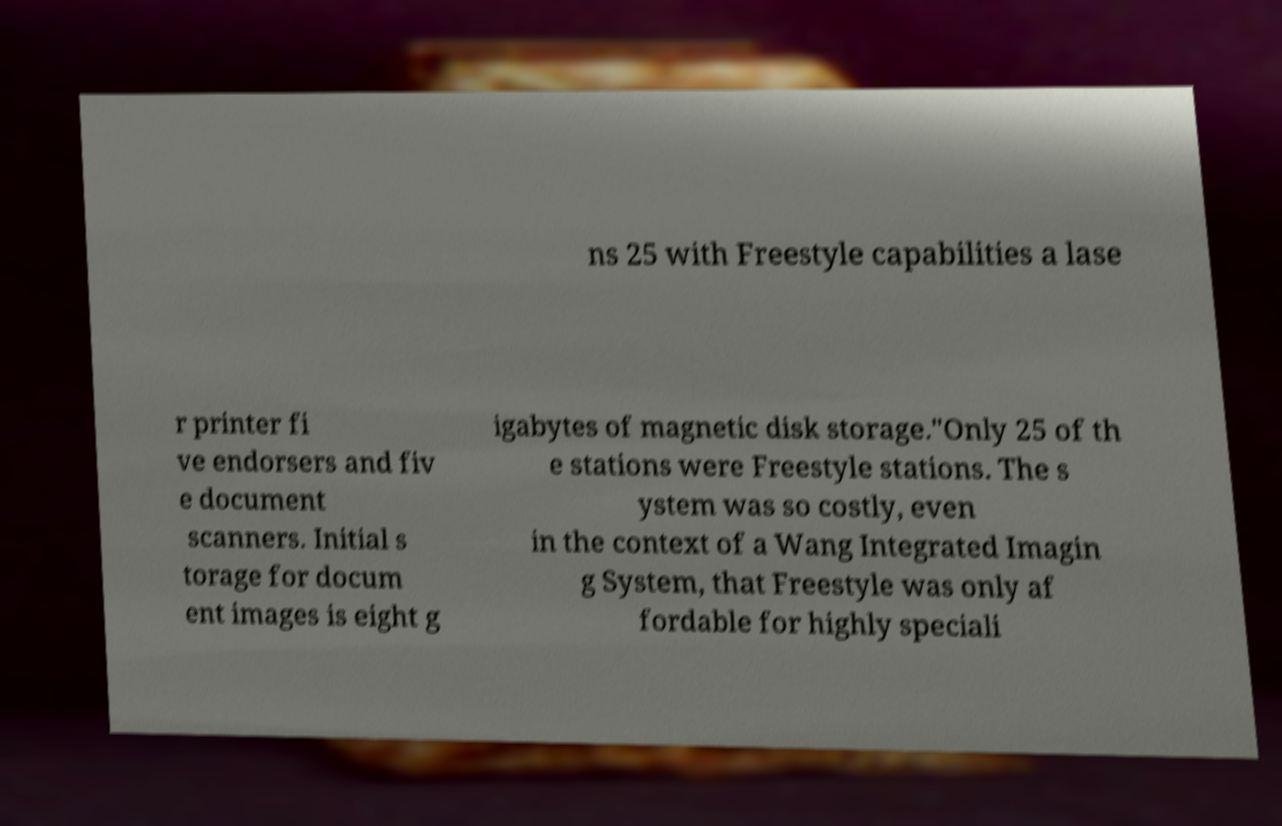Please read and relay the text visible in this image. What does it say? ns 25 with Freestyle capabilities a lase r printer fi ve endorsers and fiv e document scanners. Initial s torage for docum ent images is eight g igabytes of magnetic disk storage."Only 25 of th e stations were Freestyle stations. The s ystem was so costly, even in the context of a Wang Integrated Imagin g System, that Freestyle was only af fordable for highly speciali 